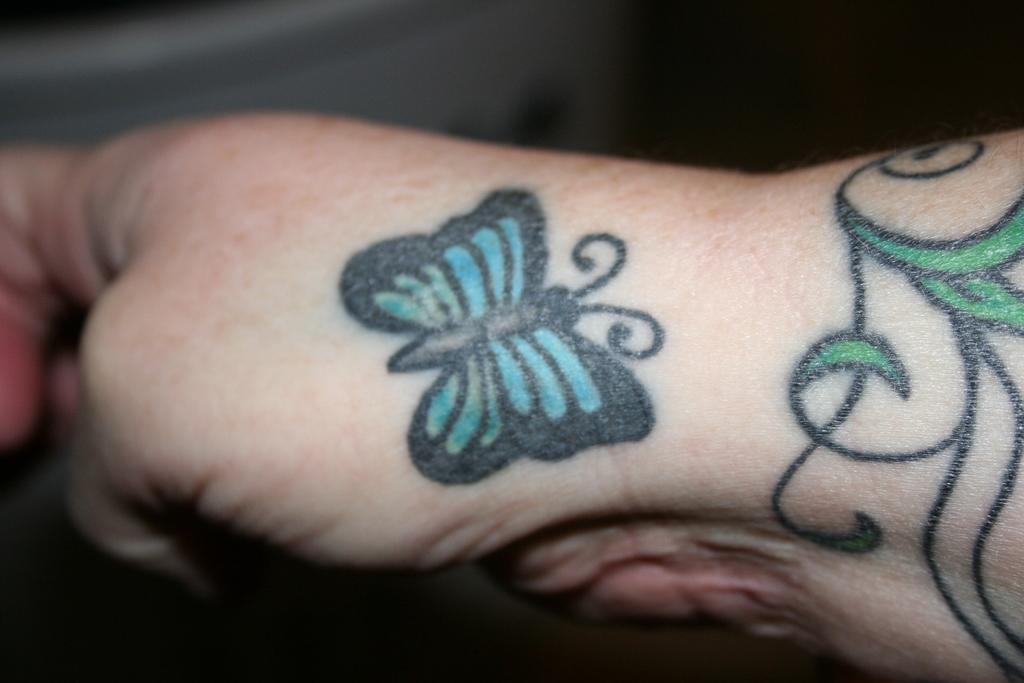Can you describe this image briefly? In this image we can see a person's hand with tattoos on it. 